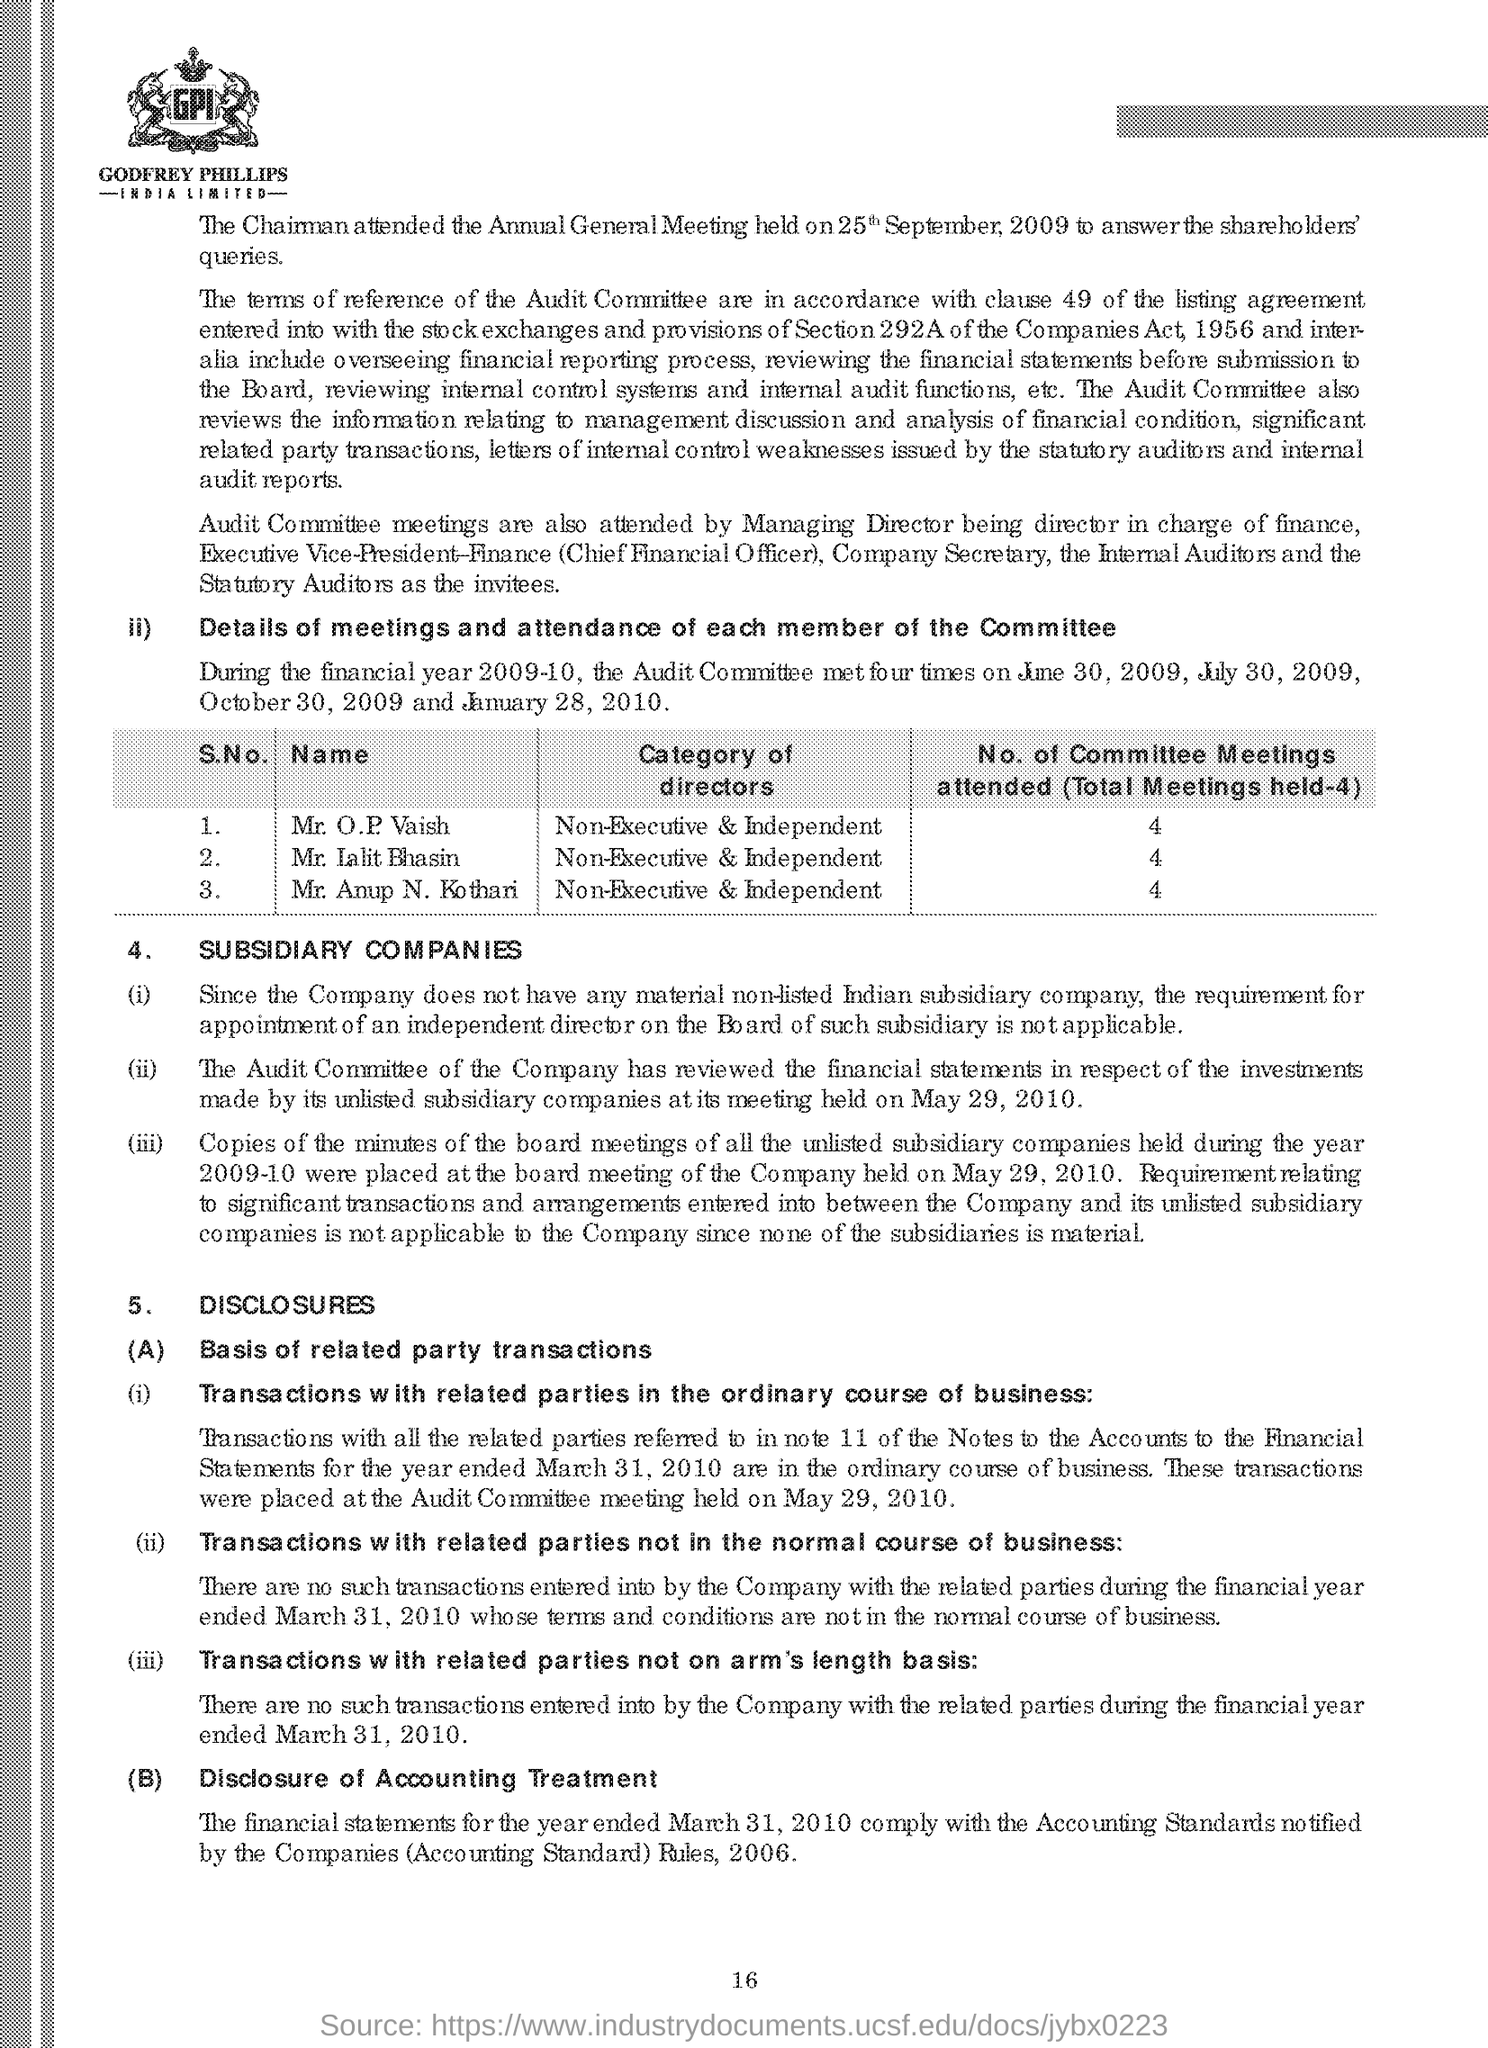Indicate a few pertinent items in this graphic. The category of directors who attend committee meetings is non-executive and independent. It is reported that three directors are in attendance at committee meetings. 